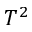<formula> <loc_0><loc_0><loc_500><loc_500>T ^ { 2 }</formula> 